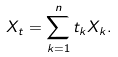<formula> <loc_0><loc_0><loc_500><loc_500>X _ { t } = \sum _ { k = 1 } ^ { n } t _ { k } X _ { k } .</formula> 